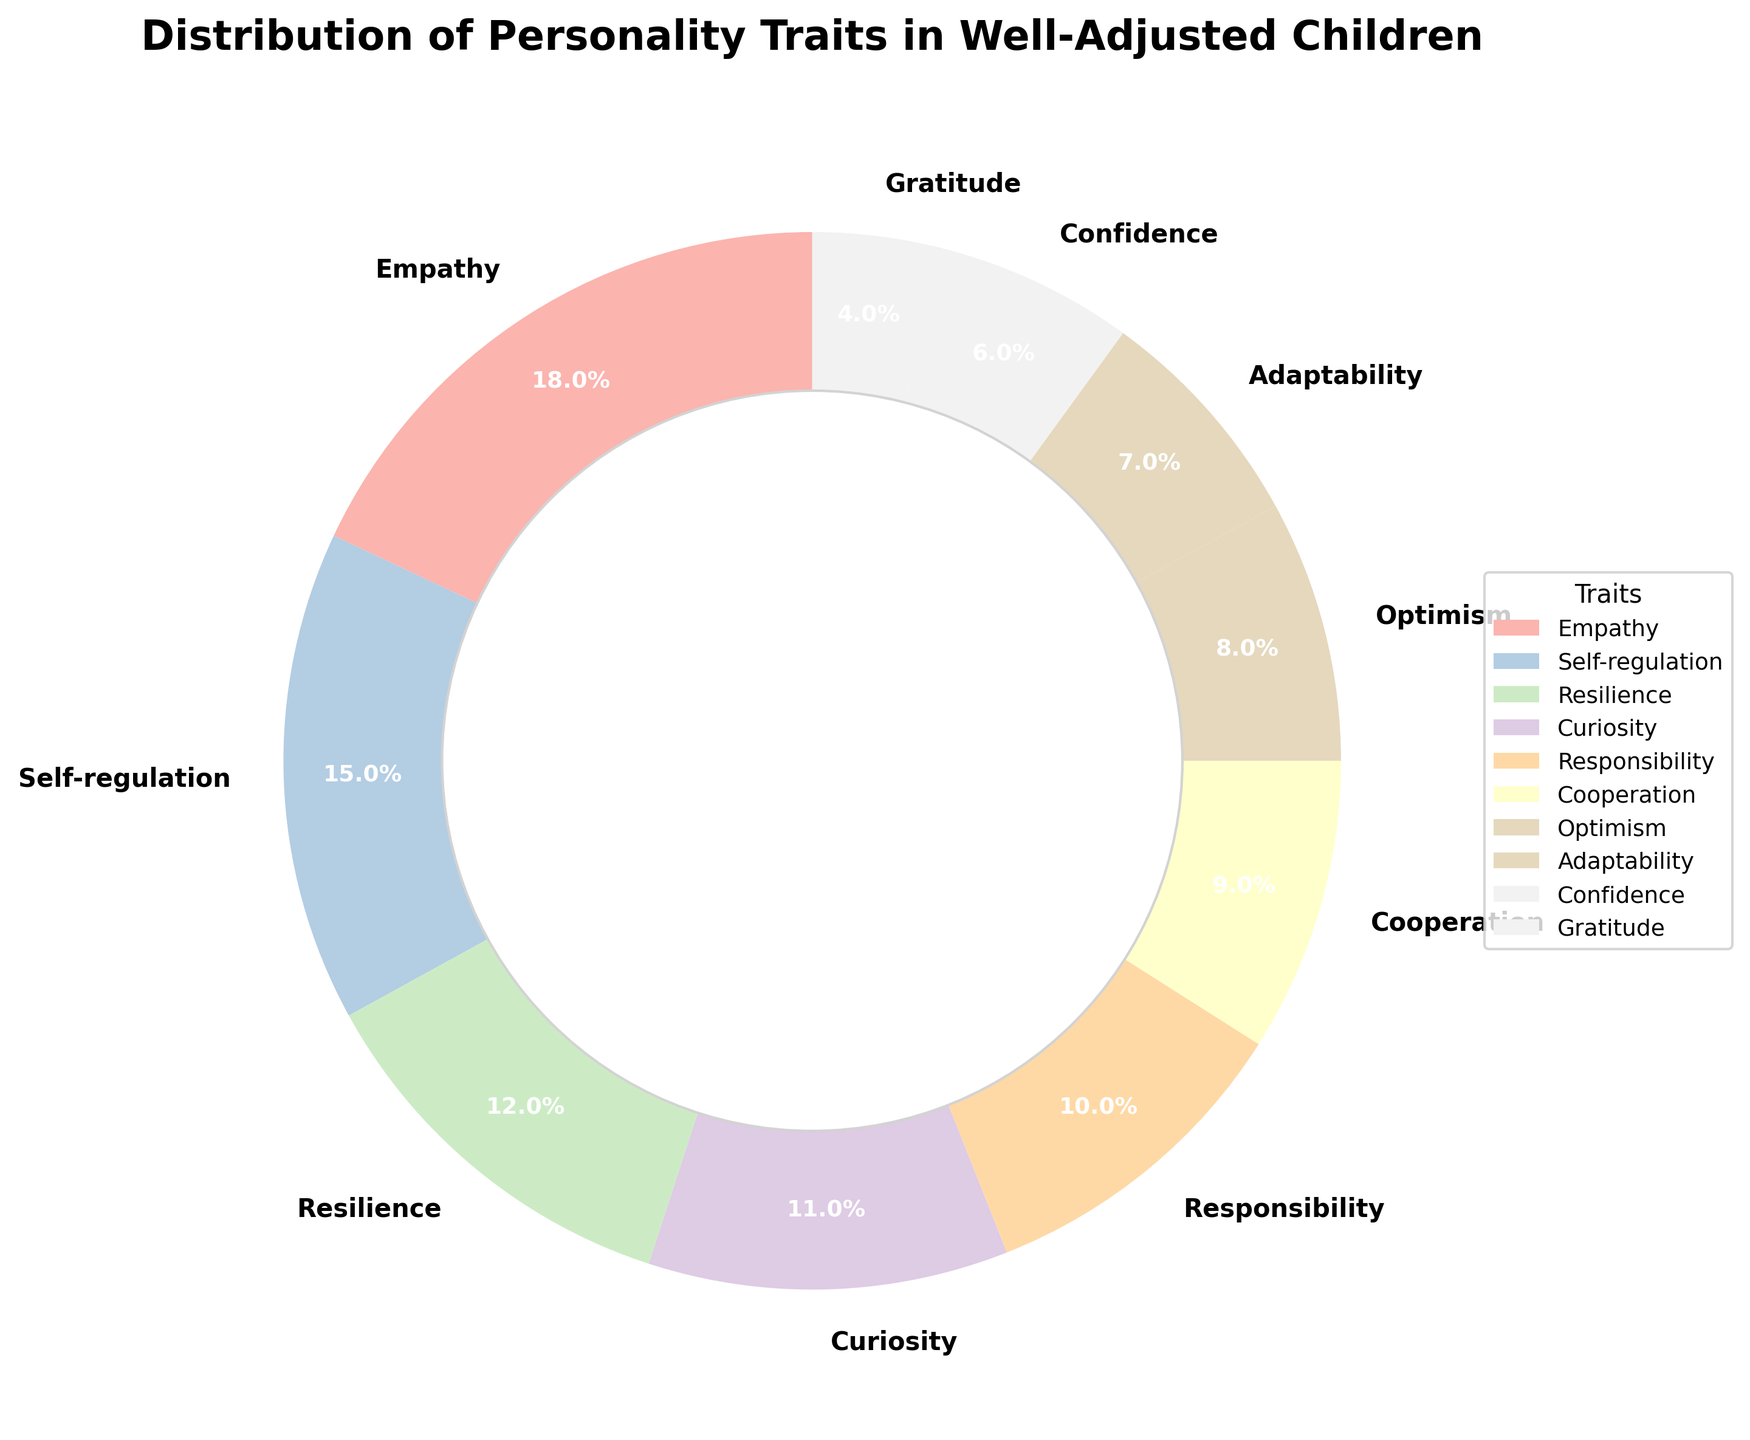Which trait has the highest percentage in well-adjusted children? Look at the pie chart and identify the trait with the largest slice and percentage label. The trait with the highest percentage is Empathy with 18%.
Answer: Empathy Which two traits combined make up the highest percentage? Identify the two traits with the highest individual percentages and sum them. Empathy and Self-regulation are the top two traits with percentages 18% and 15% respectively, making a total of 33%.
Answer: Empathy and Self-regulation Which trait accounts for a lower percentage, Adaptability or Confidence? Compare the percentage slices of Adaptability and Confidence directly from the pie chart. Adaptability is 7% and Confidence is 6%, so Confidence accounts for a lower percentage.
Answer: Confidence What is the combined percentage of traits that focus on emotional understanding and positivity, such as Empathy, Optimism, and Gratitude? Sum the percentages of the traits that fit the given criteria: Empathy (18%), Optimism (8%), and Gratitude (4%), which together total 30%.
Answer: 30% How do the percentages for Responsibility and Cooperation compare? Directly compare the percentage slices of Responsibility and Cooperation. Responsibility is 10% while Cooperation is 9%, making Responsibility slightly higher.
Answer: Responsibility By what percentage does the trait with the highest percentage exceed the trait with the lowest percentage? Calculate the difference between the percentages of the highest (Empathy, 18%) and lowest (Gratitude, 4%) traits. 18% - 4% = 14%.
Answer: 14% Which trait is visually represented between Curiosity and Responsibility but has a lower percentage than both? Identify the trait that lies between Curiosity (11%) and Responsibility (10%) and has a lower percentage than both. Cooperation is positioned between them with 9%.
Answer: Cooperation What is the average percentage of the top three traits? Calculate the average of the percentages of the top three traits: Empathy (18%), Self-regulation (15%), and Resilience (12%). The sum is 45% and the average is 45% / 3 = 15%.
Answer: 15% How many traits have a percentage greater than 10%? Count the number of traits whose percentages are greater than 10% by checking each slice. Traits with greater than 10% are Empathy (18%), Self-regulation (15%), Resilience (12%), and Curiosity (11%), totaling 4 traits.
Answer: 4 Which color represents the smallest percentage trait? Identify the color of the smallest slice in the pie chart, representing Gratitude which is 4%.
Answer: Color representing Gratitude 